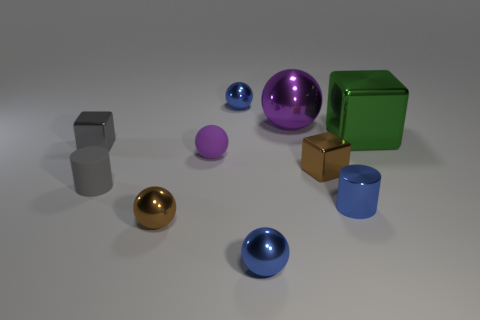Subtract all gray cubes. How many blue balls are left? 2 Subtract all big purple shiny balls. How many balls are left? 4 Subtract 1 balls. How many balls are left? 4 Subtract all purple balls. How many balls are left? 3 Subtract all red spheres. Subtract all cyan cylinders. How many spheres are left? 5 Subtract all cylinders. How many objects are left? 8 Add 4 big purple balls. How many big purple balls are left? 5 Add 4 small purple matte things. How many small purple matte things exist? 5 Subtract 1 brown balls. How many objects are left? 9 Subtract all gray cylinders. Subtract all large metal balls. How many objects are left? 8 